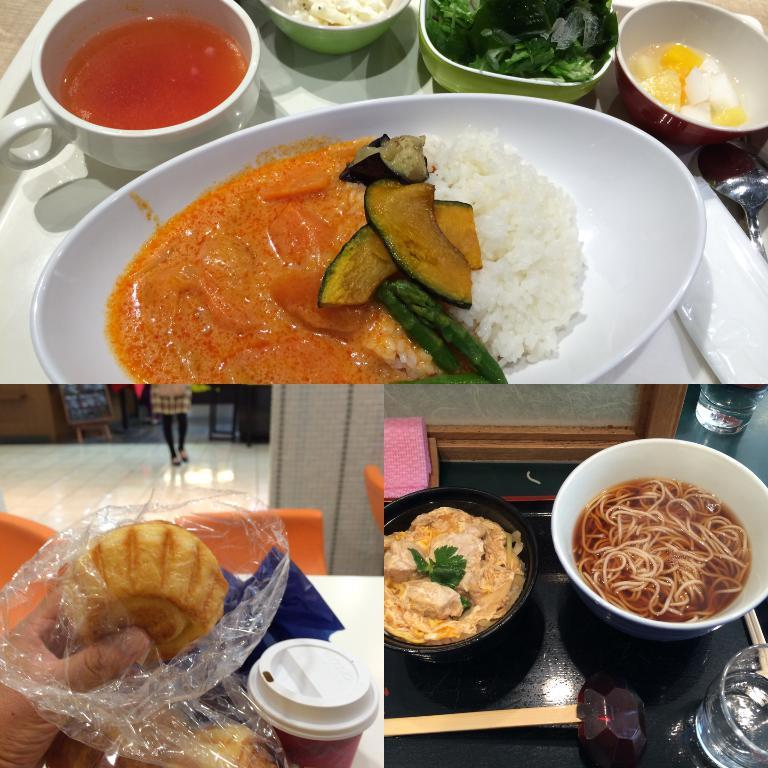What type of visual composition is the image? The image is a collage of pictures. What is the subject matter of the pictures in the collage? The pictures depict food. How does the engine affect the flight of the food in the image? There is no engine or flight present in the image; it is a collage of food pictures. 